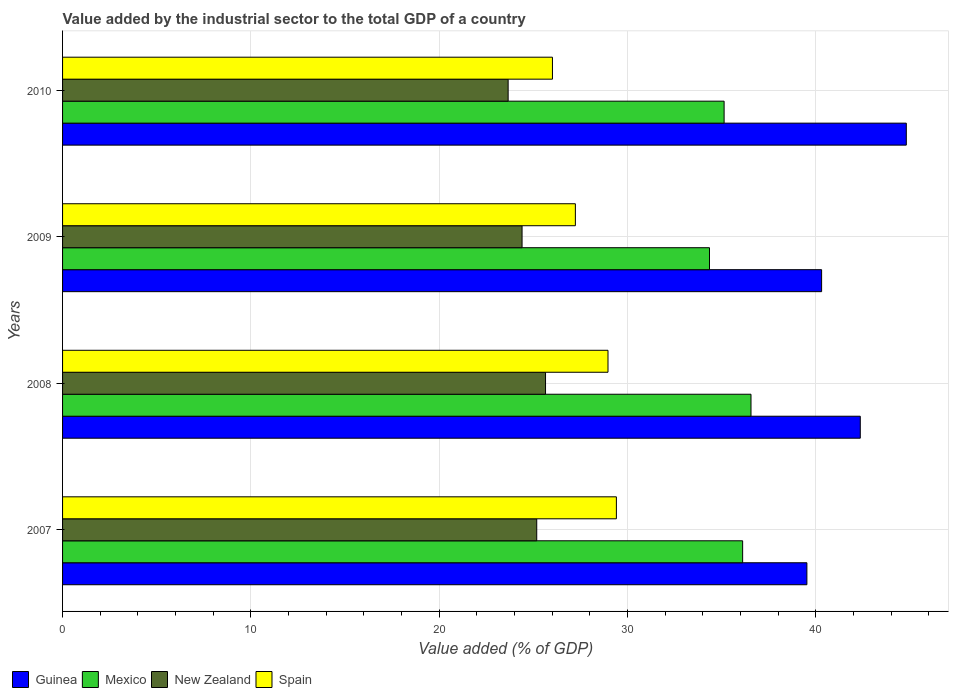How many different coloured bars are there?
Your response must be concise. 4. How many groups of bars are there?
Provide a succinct answer. 4. Are the number of bars on each tick of the Y-axis equal?
Keep it short and to the point. Yes. How many bars are there on the 1st tick from the top?
Offer a terse response. 4. How many bars are there on the 3rd tick from the bottom?
Ensure brevity in your answer.  4. What is the label of the 2nd group of bars from the top?
Your answer should be very brief. 2009. What is the value added by the industrial sector to the total GDP in Mexico in 2007?
Give a very brief answer. 36.11. Across all years, what is the maximum value added by the industrial sector to the total GDP in Spain?
Your answer should be compact. 29.41. Across all years, what is the minimum value added by the industrial sector to the total GDP in Guinea?
Keep it short and to the point. 39.52. What is the total value added by the industrial sector to the total GDP in New Zealand in the graph?
Keep it short and to the point. 98.88. What is the difference between the value added by the industrial sector to the total GDP in New Zealand in 2007 and that in 2008?
Provide a short and direct response. -0.47. What is the difference between the value added by the industrial sector to the total GDP in Mexico in 2009 and the value added by the industrial sector to the total GDP in Guinea in 2007?
Make the answer very short. -5.17. What is the average value added by the industrial sector to the total GDP in New Zealand per year?
Your answer should be compact. 24.72. In the year 2008, what is the difference between the value added by the industrial sector to the total GDP in New Zealand and value added by the industrial sector to the total GDP in Guinea?
Provide a succinct answer. -16.71. What is the ratio of the value added by the industrial sector to the total GDP in New Zealand in 2008 to that in 2010?
Provide a short and direct response. 1.08. Is the value added by the industrial sector to the total GDP in Mexico in 2008 less than that in 2010?
Your answer should be very brief. No. What is the difference between the highest and the second highest value added by the industrial sector to the total GDP in Spain?
Ensure brevity in your answer.  0.45. What is the difference between the highest and the lowest value added by the industrial sector to the total GDP in Spain?
Ensure brevity in your answer.  3.4. Is the sum of the value added by the industrial sector to the total GDP in Mexico in 2008 and 2010 greater than the maximum value added by the industrial sector to the total GDP in Guinea across all years?
Give a very brief answer. Yes. Is it the case that in every year, the sum of the value added by the industrial sector to the total GDP in New Zealand and value added by the industrial sector to the total GDP in Mexico is greater than the sum of value added by the industrial sector to the total GDP in Spain and value added by the industrial sector to the total GDP in Guinea?
Your response must be concise. No. What does the 4th bar from the top in 2009 represents?
Give a very brief answer. Guinea. How many bars are there?
Offer a very short reply. 16. Are all the bars in the graph horizontal?
Give a very brief answer. Yes. Are the values on the major ticks of X-axis written in scientific E-notation?
Make the answer very short. No. Where does the legend appear in the graph?
Ensure brevity in your answer.  Bottom left. How many legend labels are there?
Offer a very short reply. 4. What is the title of the graph?
Your answer should be very brief. Value added by the industrial sector to the total GDP of a country. What is the label or title of the X-axis?
Your response must be concise. Value added (% of GDP). What is the Value added (% of GDP) in Guinea in 2007?
Ensure brevity in your answer.  39.52. What is the Value added (% of GDP) in Mexico in 2007?
Your answer should be very brief. 36.11. What is the Value added (% of GDP) of New Zealand in 2007?
Your answer should be very brief. 25.18. What is the Value added (% of GDP) in Spain in 2007?
Provide a short and direct response. 29.41. What is the Value added (% of GDP) in Guinea in 2008?
Your answer should be very brief. 42.36. What is the Value added (% of GDP) in Mexico in 2008?
Offer a terse response. 36.56. What is the Value added (% of GDP) of New Zealand in 2008?
Your response must be concise. 25.65. What is the Value added (% of GDP) of Spain in 2008?
Offer a very short reply. 28.96. What is the Value added (% of GDP) in Guinea in 2009?
Provide a short and direct response. 40.31. What is the Value added (% of GDP) in Mexico in 2009?
Your answer should be compact. 34.35. What is the Value added (% of GDP) of New Zealand in 2009?
Provide a succinct answer. 24.4. What is the Value added (% of GDP) in Spain in 2009?
Your response must be concise. 27.23. What is the Value added (% of GDP) in Guinea in 2010?
Keep it short and to the point. 44.8. What is the Value added (% of GDP) of Mexico in 2010?
Provide a short and direct response. 35.13. What is the Value added (% of GDP) in New Zealand in 2010?
Provide a succinct answer. 23.66. What is the Value added (% of GDP) in Spain in 2010?
Provide a short and direct response. 26.01. Across all years, what is the maximum Value added (% of GDP) in Guinea?
Make the answer very short. 44.8. Across all years, what is the maximum Value added (% of GDP) of Mexico?
Ensure brevity in your answer.  36.56. Across all years, what is the maximum Value added (% of GDP) in New Zealand?
Offer a very short reply. 25.65. Across all years, what is the maximum Value added (% of GDP) of Spain?
Offer a very short reply. 29.41. Across all years, what is the minimum Value added (% of GDP) in Guinea?
Offer a very short reply. 39.52. Across all years, what is the minimum Value added (% of GDP) of Mexico?
Keep it short and to the point. 34.35. Across all years, what is the minimum Value added (% of GDP) in New Zealand?
Offer a very short reply. 23.66. Across all years, what is the minimum Value added (% of GDP) in Spain?
Offer a very short reply. 26.01. What is the total Value added (% of GDP) in Guinea in the graph?
Give a very brief answer. 166.99. What is the total Value added (% of GDP) in Mexico in the graph?
Your answer should be compact. 142.15. What is the total Value added (% of GDP) of New Zealand in the graph?
Your answer should be very brief. 98.88. What is the total Value added (% of GDP) in Spain in the graph?
Ensure brevity in your answer.  111.61. What is the difference between the Value added (% of GDP) of Guinea in 2007 and that in 2008?
Offer a very short reply. -2.84. What is the difference between the Value added (% of GDP) of Mexico in 2007 and that in 2008?
Provide a succinct answer. -0.44. What is the difference between the Value added (% of GDP) in New Zealand in 2007 and that in 2008?
Your answer should be compact. -0.47. What is the difference between the Value added (% of GDP) in Spain in 2007 and that in 2008?
Give a very brief answer. 0.45. What is the difference between the Value added (% of GDP) in Guinea in 2007 and that in 2009?
Your answer should be very brief. -0.78. What is the difference between the Value added (% of GDP) of Mexico in 2007 and that in 2009?
Provide a succinct answer. 1.76. What is the difference between the Value added (% of GDP) of New Zealand in 2007 and that in 2009?
Offer a terse response. 0.78. What is the difference between the Value added (% of GDP) of Spain in 2007 and that in 2009?
Make the answer very short. 2.18. What is the difference between the Value added (% of GDP) of Guinea in 2007 and that in 2010?
Make the answer very short. -5.28. What is the difference between the Value added (% of GDP) in Mexico in 2007 and that in 2010?
Your answer should be very brief. 0.98. What is the difference between the Value added (% of GDP) in New Zealand in 2007 and that in 2010?
Make the answer very short. 1.52. What is the difference between the Value added (% of GDP) in Spain in 2007 and that in 2010?
Provide a short and direct response. 3.4. What is the difference between the Value added (% of GDP) of Guinea in 2008 and that in 2009?
Give a very brief answer. 2.05. What is the difference between the Value added (% of GDP) of Mexico in 2008 and that in 2009?
Keep it short and to the point. 2.2. What is the difference between the Value added (% of GDP) in New Zealand in 2008 and that in 2009?
Ensure brevity in your answer.  1.25. What is the difference between the Value added (% of GDP) in Spain in 2008 and that in 2009?
Ensure brevity in your answer.  1.73. What is the difference between the Value added (% of GDP) of Guinea in 2008 and that in 2010?
Offer a terse response. -2.44. What is the difference between the Value added (% of GDP) in Mexico in 2008 and that in 2010?
Your answer should be compact. 1.43. What is the difference between the Value added (% of GDP) in New Zealand in 2008 and that in 2010?
Your response must be concise. 1.98. What is the difference between the Value added (% of GDP) of Spain in 2008 and that in 2010?
Provide a short and direct response. 2.95. What is the difference between the Value added (% of GDP) of Guinea in 2009 and that in 2010?
Provide a short and direct response. -4.5. What is the difference between the Value added (% of GDP) of Mexico in 2009 and that in 2010?
Ensure brevity in your answer.  -0.78. What is the difference between the Value added (% of GDP) in New Zealand in 2009 and that in 2010?
Offer a terse response. 0.74. What is the difference between the Value added (% of GDP) in Spain in 2009 and that in 2010?
Provide a succinct answer. 1.22. What is the difference between the Value added (% of GDP) in Guinea in 2007 and the Value added (% of GDP) in Mexico in 2008?
Keep it short and to the point. 2.97. What is the difference between the Value added (% of GDP) in Guinea in 2007 and the Value added (% of GDP) in New Zealand in 2008?
Your answer should be very brief. 13.88. What is the difference between the Value added (% of GDP) of Guinea in 2007 and the Value added (% of GDP) of Spain in 2008?
Provide a short and direct response. 10.56. What is the difference between the Value added (% of GDP) of Mexico in 2007 and the Value added (% of GDP) of New Zealand in 2008?
Offer a terse response. 10.47. What is the difference between the Value added (% of GDP) of Mexico in 2007 and the Value added (% of GDP) of Spain in 2008?
Make the answer very short. 7.15. What is the difference between the Value added (% of GDP) of New Zealand in 2007 and the Value added (% of GDP) of Spain in 2008?
Provide a succinct answer. -3.78. What is the difference between the Value added (% of GDP) in Guinea in 2007 and the Value added (% of GDP) in Mexico in 2009?
Provide a short and direct response. 5.17. What is the difference between the Value added (% of GDP) of Guinea in 2007 and the Value added (% of GDP) of New Zealand in 2009?
Offer a terse response. 15.12. What is the difference between the Value added (% of GDP) in Guinea in 2007 and the Value added (% of GDP) in Spain in 2009?
Your answer should be very brief. 12.29. What is the difference between the Value added (% of GDP) of Mexico in 2007 and the Value added (% of GDP) of New Zealand in 2009?
Offer a very short reply. 11.71. What is the difference between the Value added (% of GDP) of Mexico in 2007 and the Value added (% of GDP) of Spain in 2009?
Your answer should be very brief. 8.88. What is the difference between the Value added (% of GDP) of New Zealand in 2007 and the Value added (% of GDP) of Spain in 2009?
Your answer should be very brief. -2.05. What is the difference between the Value added (% of GDP) in Guinea in 2007 and the Value added (% of GDP) in Mexico in 2010?
Make the answer very short. 4.4. What is the difference between the Value added (% of GDP) in Guinea in 2007 and the Value added (% of GDP) in New Zealand in 2010?
Provide a short and direct response. 15.86. What is the difference between the Value added (% of GDP) in Guinea in 2007 and the Value added (% of GDP) in Spain in 2010?
Provide a short and direct response. 13.51. What is the difference between the Value added (% of GDP) in Mexico in 2007 and the Value added (% of GDP) in New Zealand in 2010?
Provide a succinct answer. 12.45. What is the difference between the Value added (% of GDP) in Mexico in 2007 and the Value added (% of GDP) in Spain in 2010?
Your answer should be compact. 10.1. What is the difference between the Value added (% of GDP) of New Zealand in 2007 and the Value added (% of GDP) of Spain in 2010?
Keep it short and to the point. -0.83. What is the difference between the Value added (% of GDP) in Guinea in 2008 and the Value added (% of GDP) in Mexico in 2009?
Offer a very short reply. 8.01. What is the difference between the Value added (% of GDP) of Guinea in 2008 and the Value added (% of GDP) of New Zealand in 2009?
Your answer should be very brief. 17.96. What is the difference between the Value added (% of GDP) in Guinea in 2008 and the Value added (% of GDP) in Spain in 2009?
Offer a very short reply. 15.13. What is the difference between the Value added (% of GDP) of Mexico in 2008 and the Value added (% of GDP) of New Zealand in 2009?
Give a very brief answer. 12.16. What is the difference between the Value added (% of GDP) in Mexico in 2008 and the Value added (% of GDP) in Spain in 2009?
Make the answer very short. 9.33. What is the difference between the Value added (% of GDP) in New Zealand in 2008 and the Value added (% of GDP) in Spain in 2009?
Keep it short and to the point. -1.58. What is the difference between the Value added (% of GDP) of Guinea in 2008 and the Value added (% of GDP) of Mexico in 2010?
Your response must be concise. 7.23. What is the difference between the Value added (% of GDP) of Guinea in 2008 and the Value added (% of GDP) of New Zealand in 2010?
Offer a very short reply. 18.7. What is the difference between the Value added (% of GDP) of Guinea in 2008 and the Value added (% of GDP) of Spain in 2010?
Make the answer very short. 16.35. What is the difference between the Value added (% of GDP) of Mexico in 2008 and the Value added (% of GDP) of New Zealand in 2010?
Offer a very short reply. 12.9. What is the difference between the Value added (% of GDP) of Mexico in 2008 and the Value added (% of GDP) of Spain in 2010?
Keep it short and to the point. 10.54. What is the difference between the Value added (% of GDP) in New Zealand in 2008 and the Value added (% of GDP) in Spain in 2010?
Provide a succinct answer. -0.37. What is the difference between the Value added (% of GDP) of Guinea in 2009 and the Value added (% of GDP) of Mexico in 2010?
Keep it short and to the point. 5.18. What is the difference between the Value added (% of GDP) of Guinea in 2009 and the Value added (% of GDP) of New Zealand in 2010?
Keep it short and to the point. 16.64. What is the difference between the Value added (% of GDP) of Guinea in 2009 and the Value added (% of GDP) of Spain in 2010?
Offer a very short reply. 14.29. What is the difference between the Value added (% of GDP) in Mexico in 2009 and the Value added (% of GDP) in New Zealand in 2010?
Provide a short and direct response. 10.69. What is the difference between the Value added (% of GDP) in Mexico in 2009 and the Value added (% of GDP) in Spain in 2010?
Give a very brief answer. 8.34. What is the difference between the Value added (% of GDP) of New Zealand in 2009 and the Value added (% of GDP) of Spain in 2010?
Provide a short and direct response. -1.61. What is the average Value added (% of GDP) in Guinea per year?
Offer a terse response. 41.75. What is the average Value added (% of GDP) in Mexico per year?
Your answer should be compact. 35.54. What is the average Value added (% of GDP) of New Zealand per year?
Your answer should be very brief. 24.72. What is the average Value added (% of GDP) in Spain per year?
Offer a terse response. 27.9. In the year 2007, what is the difference between the Value added (% of GDP) of Guinea and Value added (% of GDP) of Mexico?
Ensure brevity in your answer.  3.41. In the year 2007, what is the difference between the Value added (% of GDP) in Guinea and Value added (% of GDP) in New Zealand?
Offer a terse response. 14.35. In the year 2007, what is the difference between the Value added (% of GDP) of Guinea and Value added (% of GDP) of Spain?
Provide a short and direct response. 10.12. In the year 2007, what is the difference between the Value added (% of GDP) of Mexico and Value added (% of GDP) of New Zealand?
Provide a succinct answer. 10.93. In the year 2007, what is the difference between the Value added (% of GDP) in Mexico and Value added (% of GDP) in Spain?
Your response must be concise. 6.7. In the year 2007, what is the difference between the Value added (% of GDP) of New Zealand and Value added (% of GDP) of Spain?
Your answer should be compact. -4.23. In the year 2008, what is the difference between the Value added (% of GDP) of Guinea and Value added (% of GDP) of Mexico?
Your answer should be very brief. 5.8. In the year 2008, what is the difference between the Value added (% of GDP) of Guinea and Value added (% of GDP) of New Zealand?
Offer a very short reply. 16.71. In the year 2008, what is the difference between the Value added (% of GDP) of Guinea and Value added (% of GDP) of Spain?
Keep it short and to the point. 13.4. In the year 2008, what is the difference between the Value added (% of GDP) in Mexico and Value added (% of GDP) in New Zealand?
Provide a succinct answer. 10.91. In the year 2008, what is the difference between the Value added (% of GDP) of Mexico and Value added (% of GDP) of Spain?
Provide a succinct answer. 7.59. In the year 2008, what is the difference between the Value added (% of GDP) in New Zealand and Value added (% of GDP) in Spain?
Keep it short and to the point. -3.32. In the year 2009, what is the difference between the Value added (% of GDP) of Guinea and Value added (% of GDP) of Mexico?
Offer a terse response. 5.95. In the year 2009, what is the difference between the Value added (% of GDP) in Guinea and Value added (% of GDP) in New Zealand?
Your answer should be compact. 15.91. In the year 2009, what is the difference between the Value added (% of GDP) of Guinea and Value added (% of GDP) of Spain?
Offer a very short reply. 13.08. In the year 2009, what is the difference between the Value added (% of GDP) in Mexico and Value added (% of GDP) in New Zealand?
Offer a very short reply. 9.95. In the year 2009, what is the difference between the Value added (% of GDP) of Mexico and Value added (% of GDP) of Spain?
Provide a succinct answer. 7.12. In the year 2009, what is the difference between the Value added (% of GDP) in New Zealand and Value added (% of GDP) in Spain?
Give a very brief answer. -2.83. In the year 2010, what is the difference between the Value added (% of GDP) of Guinea and Value added (% of GDP) of Mexico?
Provide a short and direct response. 9.67. In the year 2010, what is the difference between the Value added (% of GDP) of Guinea and Value added (% of GDP) of New Zealand?
Give a very brief answer. 21.14. In the year 2010, what is the difference between the Value added (% of GDP) of Guinea and Value added (% of GDP) of Spain?
Ensure brevity in your answer.  18.79. In the year 2010, what is the difference between the Value added (% of GDP) of Mexico and Value added (% of GDP) of New Zealand?
Keep it short and to the point. 11.47. In the year 2010, what is the difference between the Value added (% of GDP) in Mexico and Value added (% of GDP) in Spain?
Your answer should be very brief. 9.12. In the year 2010, what is the difference between the Value added (% of GDP) of New Zealand and Value added (% of GDP) of Spain?
Make the answer very short. -2.35. What is the ratio of the Value added (% of GDP) of Guinea in 2007 to that in 2008?
Keep it short and to the point. 0.93. What is the ratio of the Value added (% of GDP) in Mexico in 2007 to that in 2008?
Your response must be concise. 0.99. What is the ratio of the Value added (% of GDP) of New Zealand in 2007 to that in 2008?
Offer a terse response. 0.98. What is the ratio of the Value added (% of GDP) of Spain in 2007 to that in 2008?
Your answer should be very brief. 1.02. What is the ratio of the Value added (% of GDP) of Guinea in 2007 to that in 2009?
Make the answer very short. 0.98. What is the ratio of the Value added (% of GDP) of Mexico in 2007 to that in 2009?
Ensure brevity in your answer.  1.05. What is the ratio of the Value added (% of GDP) in New Zealand in 2007 to that in 2009?
Offer a very short reply. 1.03. What is the ratio of the Value added (% of GDP) in Spain in 2007 to that in 2009?
Provide a succinct answer. 1.08. What is the ratio of the Value added (% of GDP) in Guinea in 2007 to that in 2010?
Your response must be concise. 0.88. What is the ratio of the Value added (% of GDP) of Mexico in 2007 to that in 2010?
Ensure brevity in your answer.  1.03. What is the ratio of the Value added (% of GDP) of New Zealand in 2007 to that in 2010?
Offer a very short reply. 1.06. What is the ratio of the Value added (% of GDP) in Spain in 2007 to that in 2010?
Offer a terse response. 1.13. What is the ratio of the Value added (% of GDP) of Guinea in 2008 to that in 2009?
Your answer should be very brief. 1.05. What is the ratio of the Value added (% of GDP) in Mexico in 2008 to that in 2009?
Provide a short and direct response. 1.06. What is the ratio of the Value added (% of GDP) in New Zealand in 2008 to that in 2009?
Your response must be concise. 1.05. What is the ratio of the Value added (% of GDP) in Spain in 2008 to that in 2009?
Give a very brief answer. 1.06. What is the ratio of the Value added (% of GDP) of Guinea in 2008 to that in 2010?
Your answer should be compact. 0.95. What is the ratio of the Value added (% of GDP) of Mexico in 2008 to that in 2010?
Make the answer very short. 1.04. What is the ratio of the Value added (% of GDP) of New Zealand in 2008 to that in 2010?
Keep it short and to the point. 1.08. What is the ratio of the Value added (% of GDP) in Spain in 2008 to that in 2010?
Your answer should be compact. 1.11. What is the ratio of the Value added (% of GDP) of Guinea in 2009 to that in 2010?
Your response must be concise. 0.9. What is the ratio of the Value added (% of GDP) of Mexico in 2009 to that in 2010?
Give a very brief answer. 0.98. What is the ratio of the Value added (% of GDP) in New Zealand in 2009 to that in 2010?
Keep it short and to the point. 1.03. What is the ratio of the Value added (% of GDP) in Spain in 2009 to that in 2010?
Offer a terse response. 1.05. What is the difference between the highest and the second highest Value added (% of GDP) of Guinea?
Your answer should be very brief. 2.44. What is the difference between the highest and the second highest Value added (% of GDP) in Mexico?
Your answer should be compact. 0.44. What is the difference between the highest and the second highest Value added (% of GDP) in New Zealand?
Provide a succinct answer. 0.47. What is the difference between the highest and the second highest Value added (% of GDP) of Spain?
Your response must be concise. 0.45. What is the difference between the highest and the lowest Value added (% of GDP) in Guinea?
Make the answer very short. 5.28. What is the difference between the highest and the lowest Value added (% of GDP) in Mexico?
Give a very brief answer. 2.2. What is the difference between the highest and the lowest Value added (% of GDP) in New Zealand?
Provide a succinct answer. 1.98. What is the difference between the highest and the lowest Value added (% of GDP) of Spain?
Your answer should be compact. 3.4. 